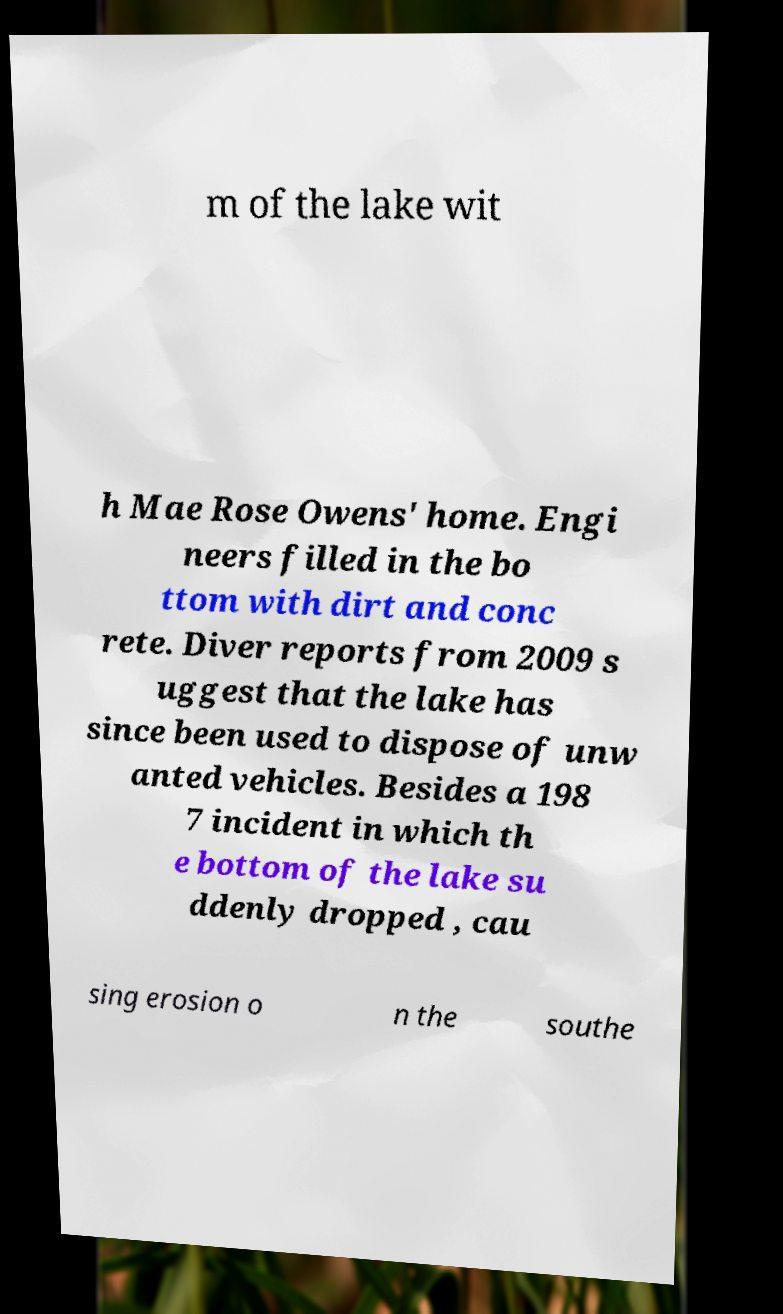For documentation purposes, I need the text within this image transcribed. Could you provide that? m of the lake wit h Mae Rose Owens' home. Engi neers filled in the bo ttom with dirt and conc rete. Diver reports from 2009 s uggest that the lake has since been used to dispose of unw anted vehicles. Besides a 198 7 incident in which th e bottom of the lake su ddenly dropped , cau sing erosion o n the southe 